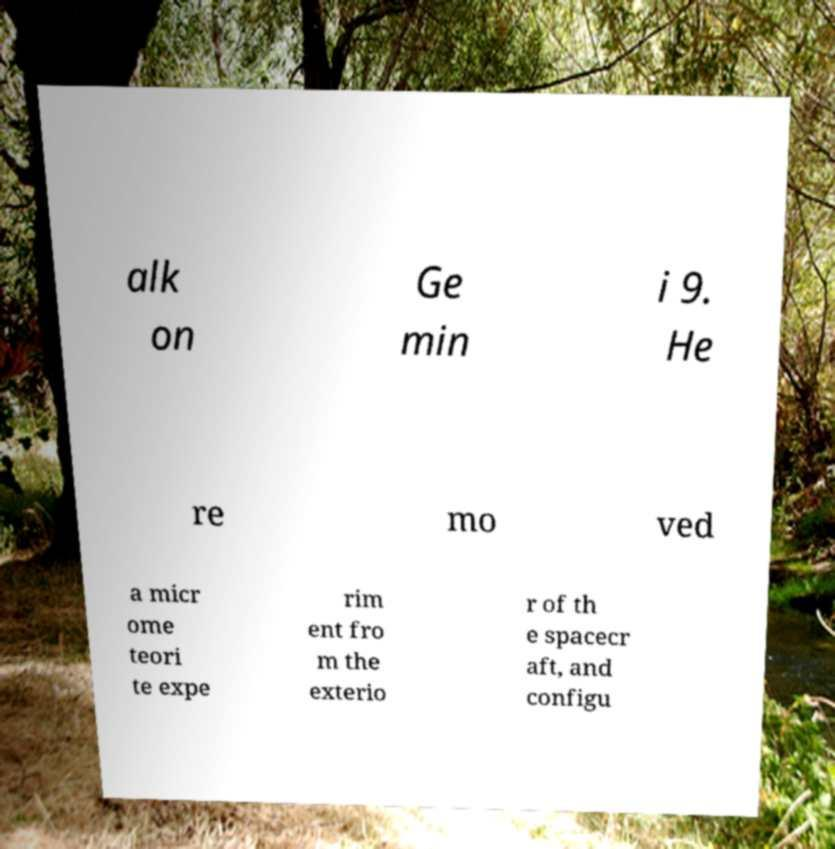There's text embedded in this image that I need extracted. Can you transcribe it verbatim? alk on Ge min i 9. He re mo ved a micr ome teori te expe rim ent fro m the exterio r of th e spacecr aft, and configu 